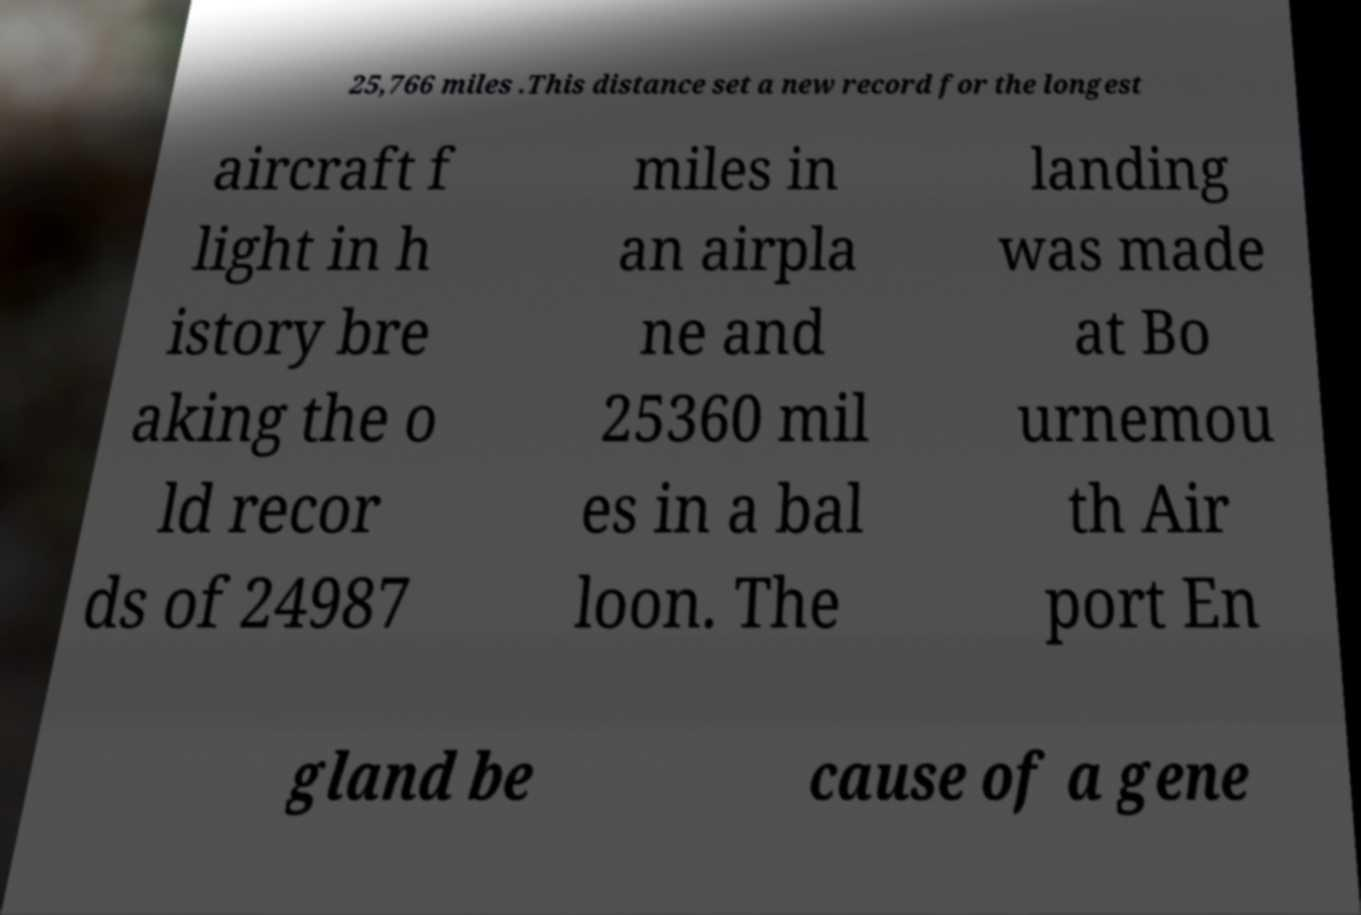Can you read and provide the text displayed in the image?This photo seems to have some interesting text. Can you extract and type it out for me? 25,766 miles .This distance set a new record for the longest aircraft f light in h istory bre aking the o ld recor ds of 24987 miles in an airpla ne and 25360 mil es in a bal loon. The landing was made at Bo urnemou th Air port En gland be cause of a gene 